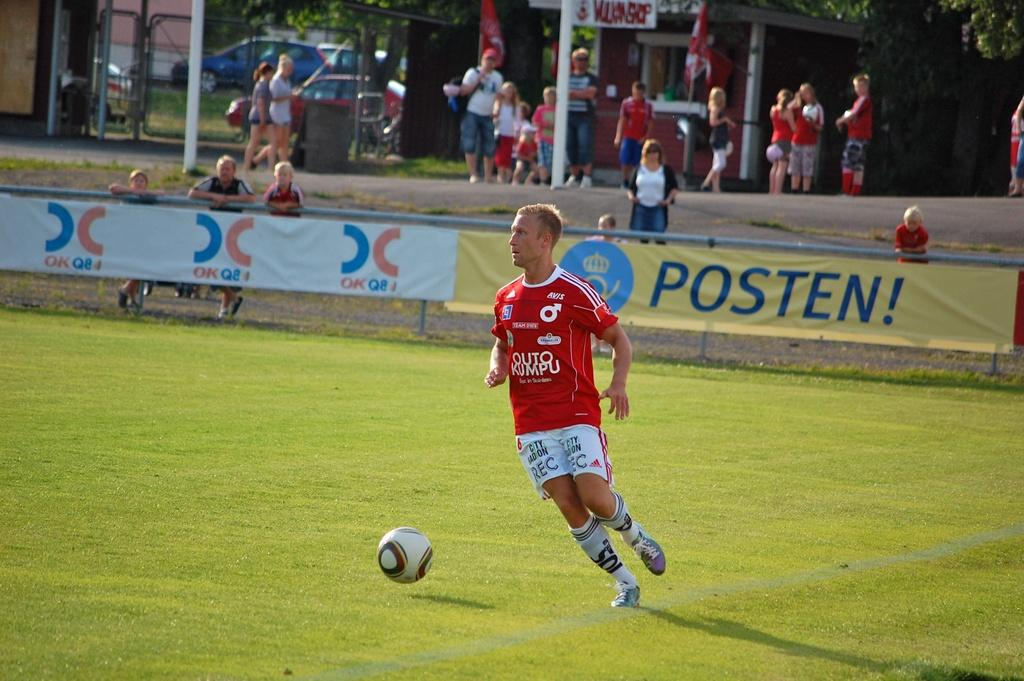<image>
Relay a brief, clear account of the picture shown. A man kicks a ball on a football field, the word Posten is visible behind him. 